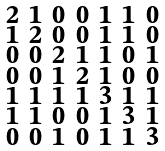Convert formula to latex. <formula><loc_0><loc_0><loc_500><loc_500>\begin{smallmatrix} 2 & 1 & 0 & 0 & 1 & 1 & 0 \\ 1 & 2 & 0 & 0 & 1 & 1 & 0 \\ 0 & 0 & 2 & 1 & 1 & 0 & 1 \\ 0 & 0 & 1 & 2 & 1 & 0 & 0 \\ 1 & 1 & 1 & 1 & 3 & 1 & 1 \\ 1 & 1 & 0 & 0 & 1 & 3 & 1 \\ 0 & 0 & 1 & 0 & 1 & 1 & 3 \end{smallmatrix}</formula> 